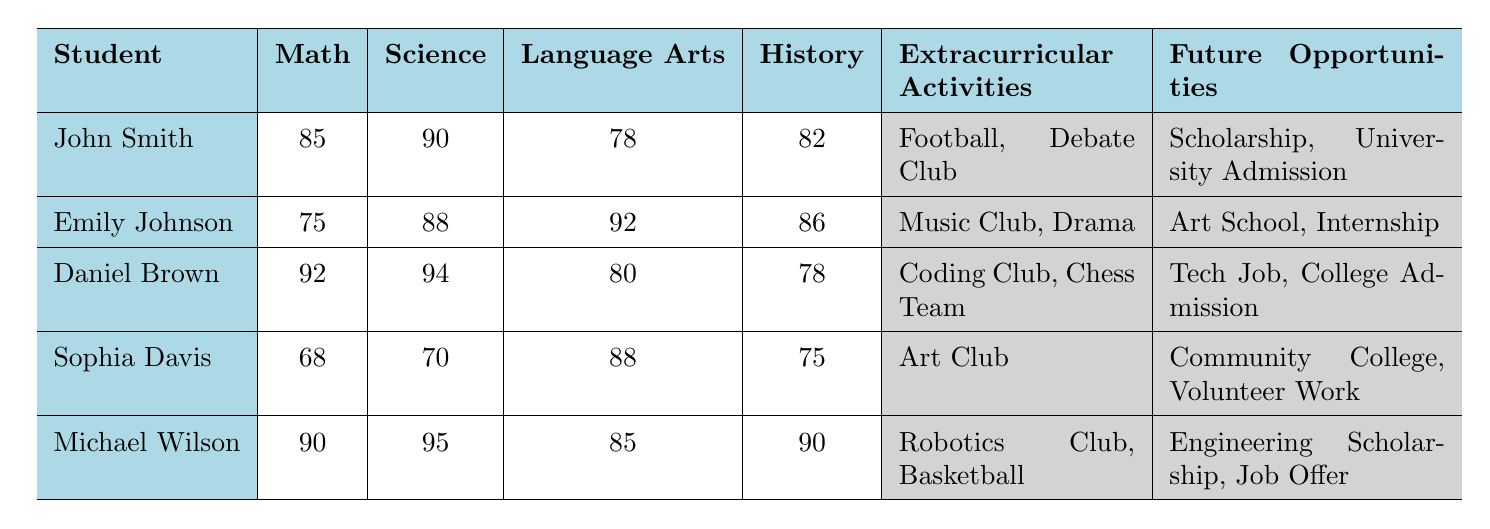What is John Smith's Science Score? According to the table, the value listed under Science Score for John Smith is clearly 90.
Answer: 90 Which student has the lowest Math Score? By checking the Math Scores of all the students listed, Sophia Davis has the lowest score at 68.
Answer: Sophia Davis What is the average Language Arts Score of all students? To calculate the average, first sum all Language Arts Scores: 78 + 92 + 80 + 88 + 85 = 423. There are 5 students, so the average is 423 / 5 = 84.6.
Answer: 84.6 Do any students have future opportunities related to scholarships? Looking through the Future Opportunities, both John Smith and Michael Wilson have opportunities related to scholarships: John has "Scholarship" and Michael has "Engineering Scholarship." Therefore, the answer is yes.
Answer: Yes Which students are involved in extracurricular activities related to technology? Examining the Extracurricular Activities, Daniel Brown is in "Coding Club," and Michael Wilson is in "Robotics Club." Therefore, both have activities related to technology.
Answer: Daniel Brown and Michael Wilson What is the difference between Daniel Brown's Math Score and Sophia Davis's Math Score? Daniel Brown's Math Score is 92 and Sophia Davis's is 68. The difference is 92 - 68 = 24.
Answer: 24 Are there any students with a Language Arts Score above 90? Both Emily Johnson (92) and Michael Wilson (85) have Language Arts Scores above 90, thus the answer is yes.
Answer: Yes Which student has the highest combined score in Math and Science? For combined scores, calculate Math and Science scores for each student. The totals are: John Smith (175), Emily Johnson (163), Daniel Brown (186), Sophia Davis (138), and Michael Wilson (185). Daniel Brown has the highest combined score of 186.
Answer: Daniel Brown How many students have at least one extracurricular activity listed? All five students have extracurricular activities listed, so the total is 5 students.
Answer: 5 